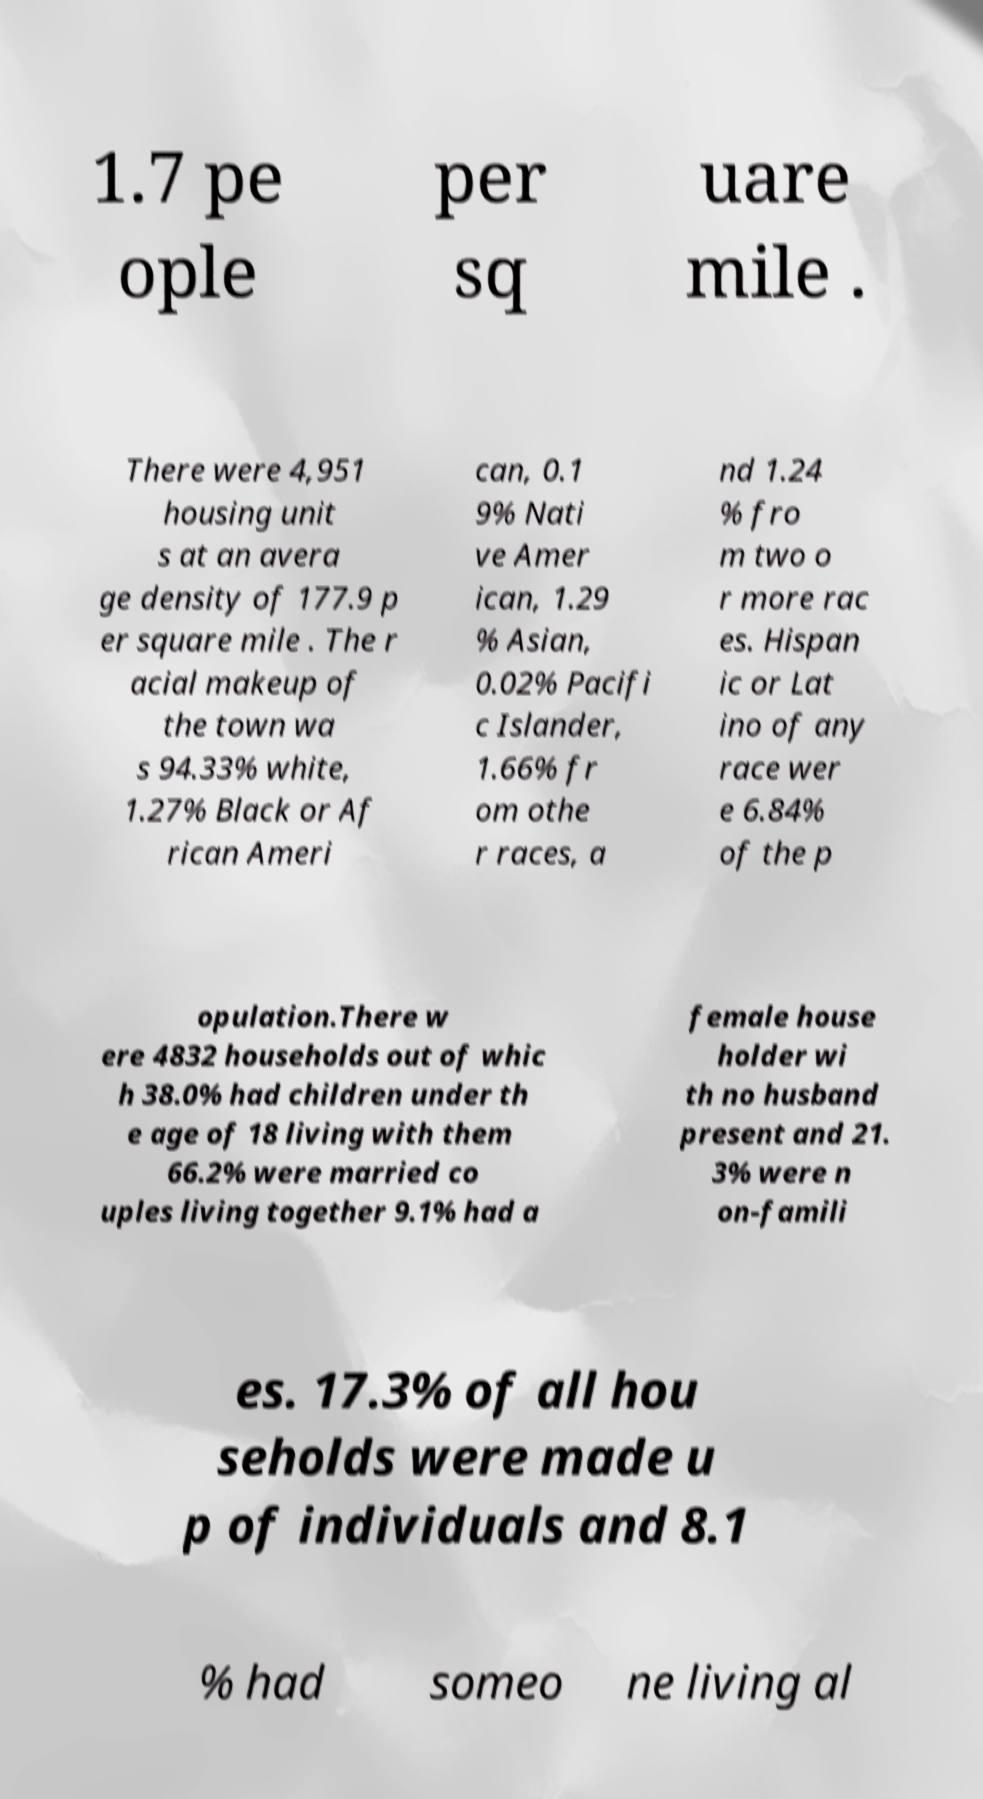Can you accurately transcribe the text from the provided image for me? 1.7 pe ople per sq uare mile . There were 4,951 housing unit s at an avera ge density of 177.9 p er square mile . The r acial makeup of the town wa s 94.33% white, 1.27% Black or Af rican Ameri can, 0.1 9% Nati ve Amer ican, 1.29 % Asian, 0.02% Pacifi c Islander, 1.66% fr om othe r races, a nd 1.24 % fro m two o r more rac es. Hispan ic or Lat ino of any race wer e 6.84% of the p opulation.There w ere 4832 households out of whic h 38.0% had children under th e age of 18 living with them 66.2% were married co uples living together 9.1% had a female house holder wi th no husband present and 21. 3% were n on-famili es. 17.3% of all hou seholds were made u p of individuals and 8.1 % had someo ne living al 